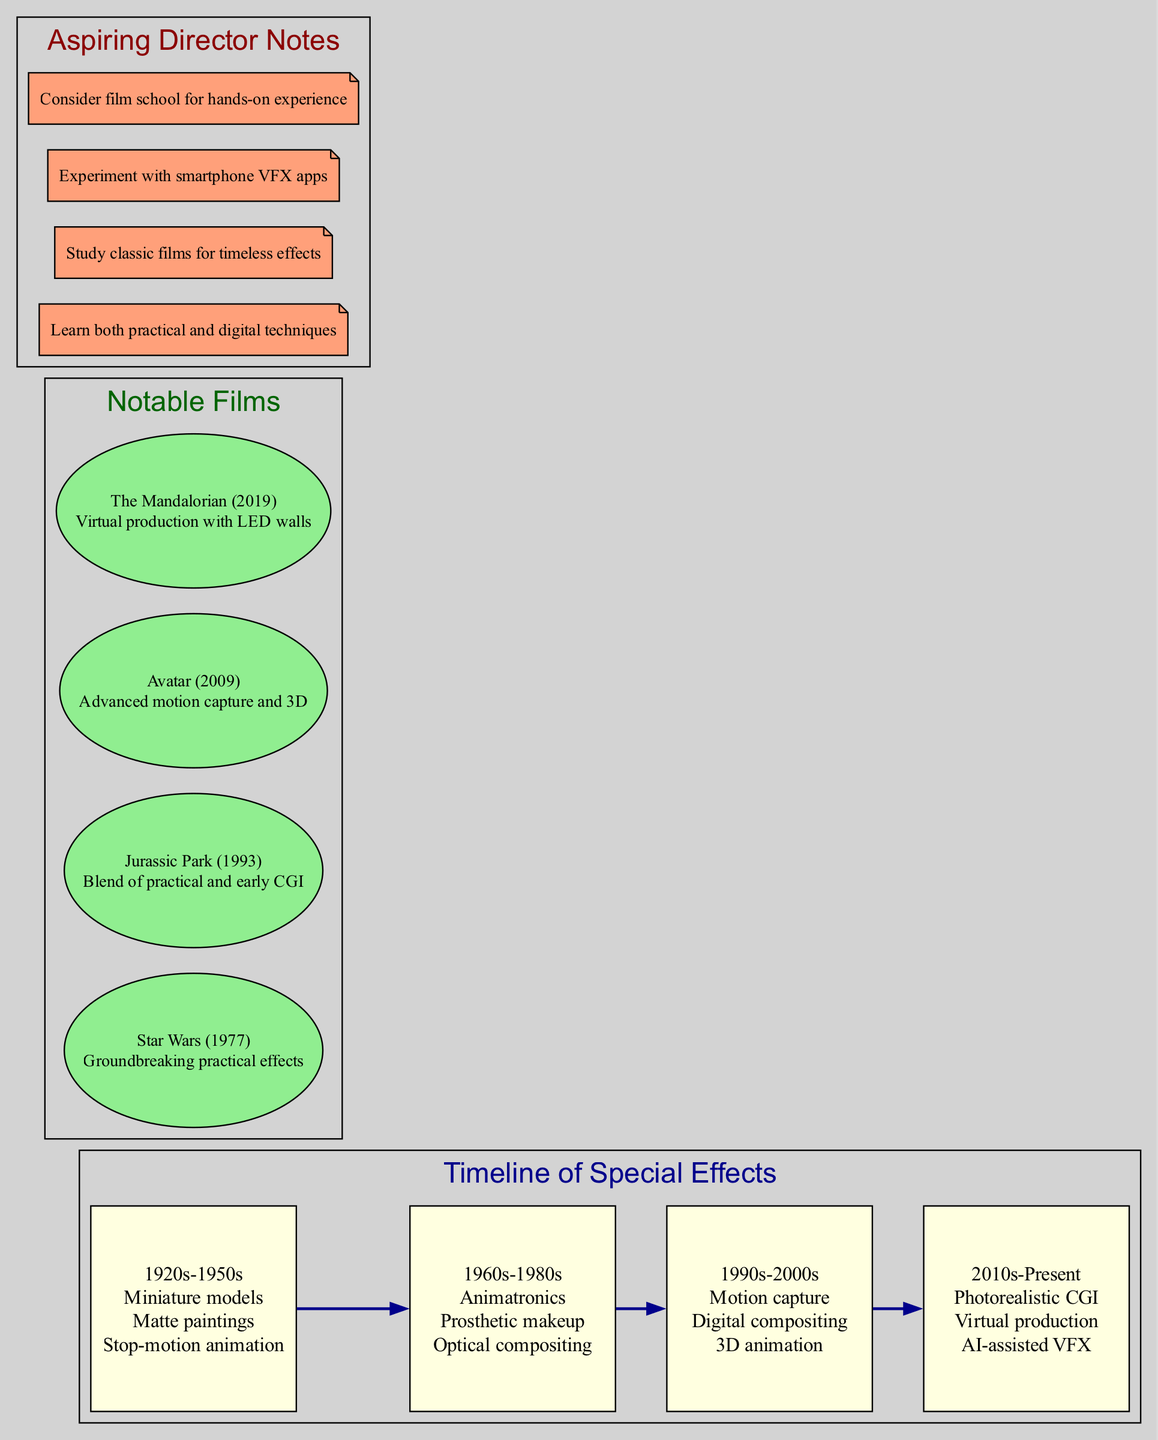What special effects techniques were used in the 1960s-1980s? The diagram indicates that during the 1960s-1980s, the techniques included animatronics, prosthetic makeup, and optical compositing. This information can be found in the timeline section corresponding to that era.
Answer: Animatronics, prosthetic makeup, optical compositing How many notable films are listed in the diagram? By looking at the diagram, there are four notable films presented within their respective section. Each one is listed separately, confirming the total number.
Answer: 4 Which notable film is known for its groundbreaking practical effects? The diagram shows that "Star Wars (1977)" is specifically noted for its groundbreaking practical effects. This is directly stated in the notable films section.
Answer: Star Wars (1977) What was one of the special effects techniques used in the 1920s-1950s? The techniques listed for the 1920s-1950s era include miniature models, matte paintings, and stop-motion animation. Any of these can be given as the answer.
Answer: Miniature models What film showcases both practical effects and early CGI? According to the diagram, "Jurassic Park (1993)" is recognized for blending practical effects with early CGI. This is explicitly mentioned alongside the film title.
Answer: Jurassic Park (1993) Which era introduced photorealistic CGI as a technique? The timeline indicates that photorealistic CGI emerged in the 2010s-Present era. This can be cross-referenced by identifying the era and its corresponding techniques.
Answer: 2010s-Present What should aspiring directors learn according to the notes? The notes recommend that aspiring directors learn both practical and digital techniques. This is highlighted clearly in the aspiring director notes section.
Answer: Practical and digital techniques Which notable film utilized virtual production techniques with LED walls? The diagram states that "The Mandalorian (2019)" utilized virtual production techniques with LED walls, clearly marked in the notable films section.
Answer: The Mandalorian (2019) Which techniques are listed for the 1990s-2000s? The techniques associated with the 1990s-2000s era include motion capture, digital compositing, and 3D animation. These can be found in that specific era section of the diagram.
Answer: Motion capture, digital compositing, 3D animation 